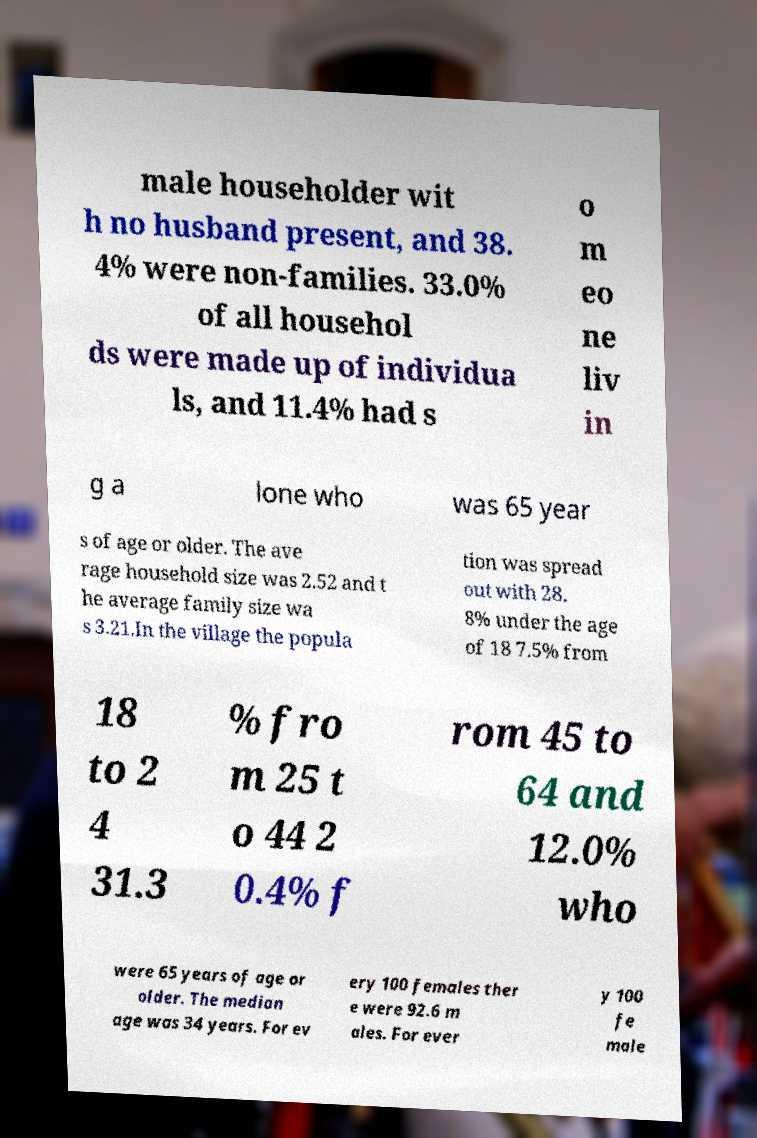Could you assist in decoding the text presented in this image and type it out clearly? male householder wit h no husband present, and 38. 4% were non-families. 33.0% of all househol ds were made up of individua ls, and 11.4% had s o m eo ne liv in g a lone who was 65 year s of age or older. The ave rage household size was 2.52 and t he average family size wa s 3.21.In the village the popula tion was spread out with 28. 8% under the age of 18 7.5% from 18 to 2 4 31.3 % fro m 25 t o 44 2 0.4% f rom 45 to 64 and 12.0% who were 65 years of age or older. The median age was 34 years. For ev ery 100 females ther e were 92.6 m ales. For ever y 100 fe male 